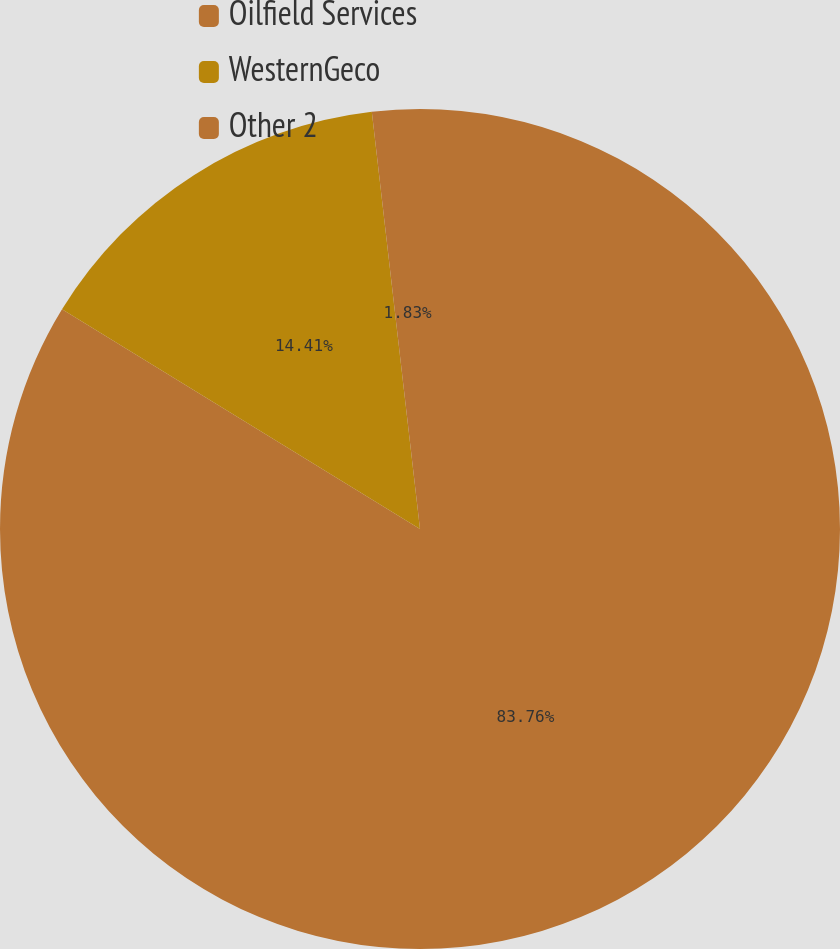Convert chart. <chart><loc_0><loc_0><loc_500><loc_500><pie_chart><fcel>Oilfield Services<fcel>WesternGeco<fcel>Other 2<nl><fcel>83.76%<fcel>14.41%<fcel>1.83%<nl></chart> 